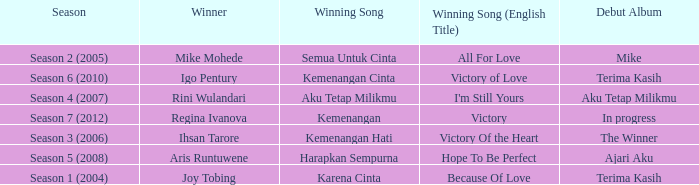Who won with the song kemenangan cinta? Igo Pentury. 